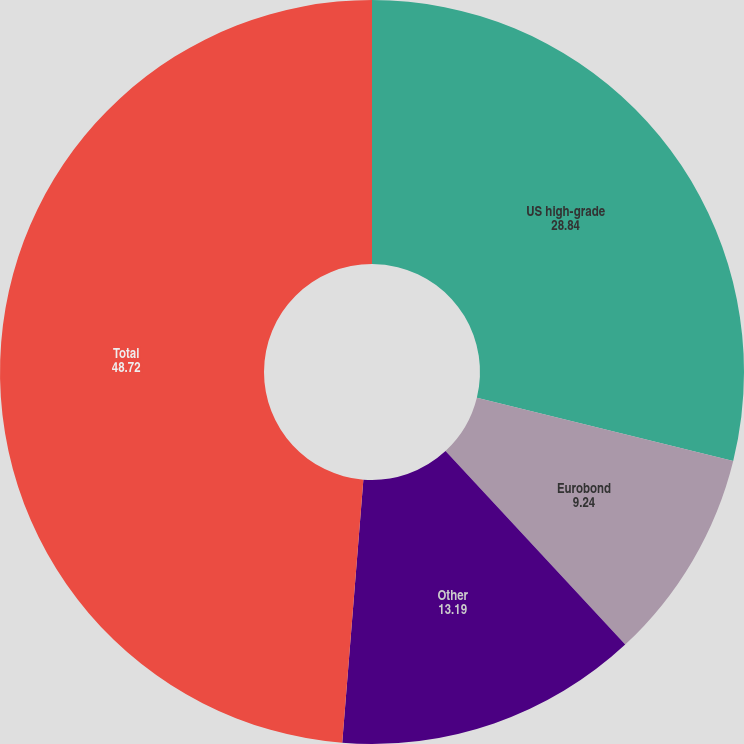<chart> <loc_0><loc_0><loc_500><loc_500><pie_chart><fcel>US high-grade<fcel>Eurobond<fcel>Other<fcel>Total<nl><fcel>28.84%<fcel>9.24%<fcel>13.19%<fcel>48.72%<nl></chart> 